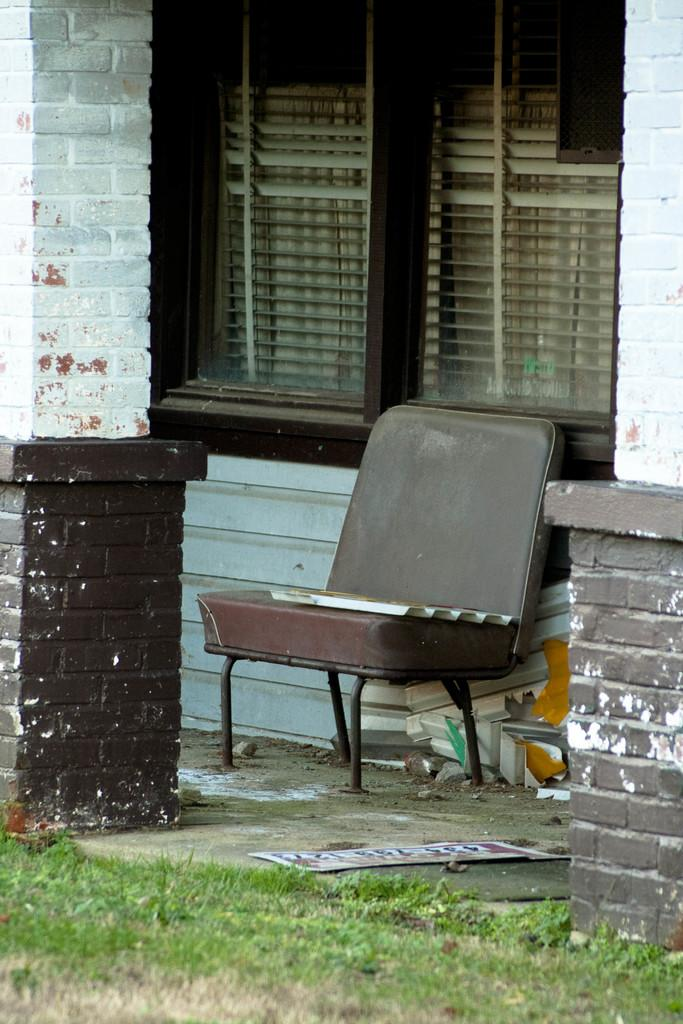What is the main object in the center of the image? There is a chair in the center of the image. What architectural features can be seen in the image? There are pillars in the image. What can be seen in the background of the image? There are windows visible in the background of the image. Can you see any veins in the chair in the image? There are no veins visible in the chair in the image, as veins are not a characteristic of chairs. 